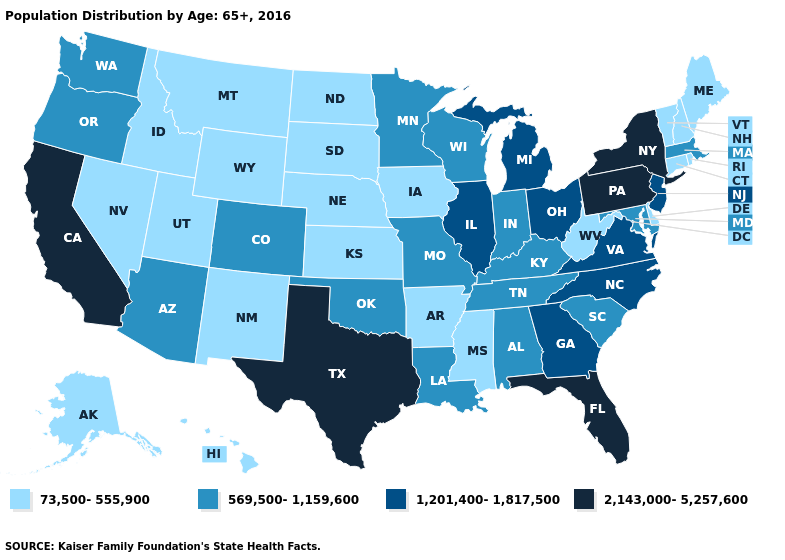Name the states that have a value in the range 73,500-555,900?
Concise answer only. Alaska, Arkansas, Connecticut, Delaware, Hawaii, Idaho, Iowa, Kansas, Maine, Mississippi, Montana, Nebraska, Nevada, New Hampshire, New Mexico, North Dakota, Rhode Island, South Dakota, Utah, Vermont, West Virginia, Wyoming. What is the lowest value in states that border Wisconsin?
Keep it brief. 73,500-555,900. What is the highest value in the USA?
Be succinct. 2,143,000-5,257,600. What is the value of Missouri?
Concise answer only. 569,500-1,159,600. Name the states that have a value in the range 73,500-555,900?
Write a very short answer. Alaska, Arkansas, Connecticut, Delaware, Hawaii, Idaho, Iowa, Kansas, Maine, Mississippi, Montana, Nebraska, Nevada, New Hampshire, New Mexico, North Dakota, Rhode Island, South Dakota, Utah, Vermont, West Virginia, Wyoming. Does Pennsylvania have the highest value in the USA?
Concise answer only. Yes. What is the lowest value in the USA?
Write a very short answer. 73,500-555,900. What is the value of Indiana?
Quick response, please. 569,500-1,159,600. Which states hav the highest value in the South?
Be succinct. Florida, Texas. What is the highest value in the West ?
Give a very brief answer. 2,143,000-5,257,600. What is the value of Virginia?
Quick response, please. 1,201,400-1,817,500. Does Tennessee have a higher value than Kentucky?
Write a very short answer. No. What is the value of Florida?
Write a very short answer. 2,143,000-5,257,600. Does Michigan have the highest value in the USA?
Give a very brief answer. No. What is the lowest value in states that border Nebraska?
Concise answer only. 73,500-555,900. 